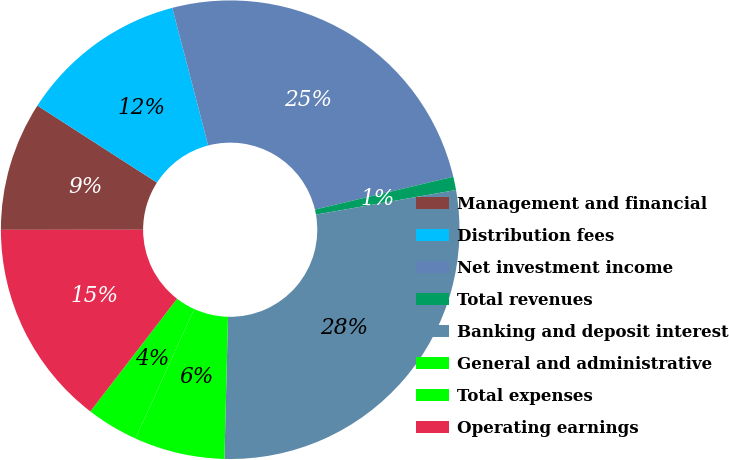<chart> <loc_0><loc_0><loc_500><loc_500><pie_chart><fcel>Management and financial<fcel>Distribution fees<fcel>Net investment income<fcel>Total revenues<fcel>Banking and deposit interest<fcel>General and administrative<fcel>Total expenses<fcel>Operating earnings<nl><fcel>9.11%<fcel>11.83%<fcel>25.35%<fcel>0.94%<fcel>28.17%<fcel>6.38%<fcel>3.66%<fcel>14.55%<nl></chart> 